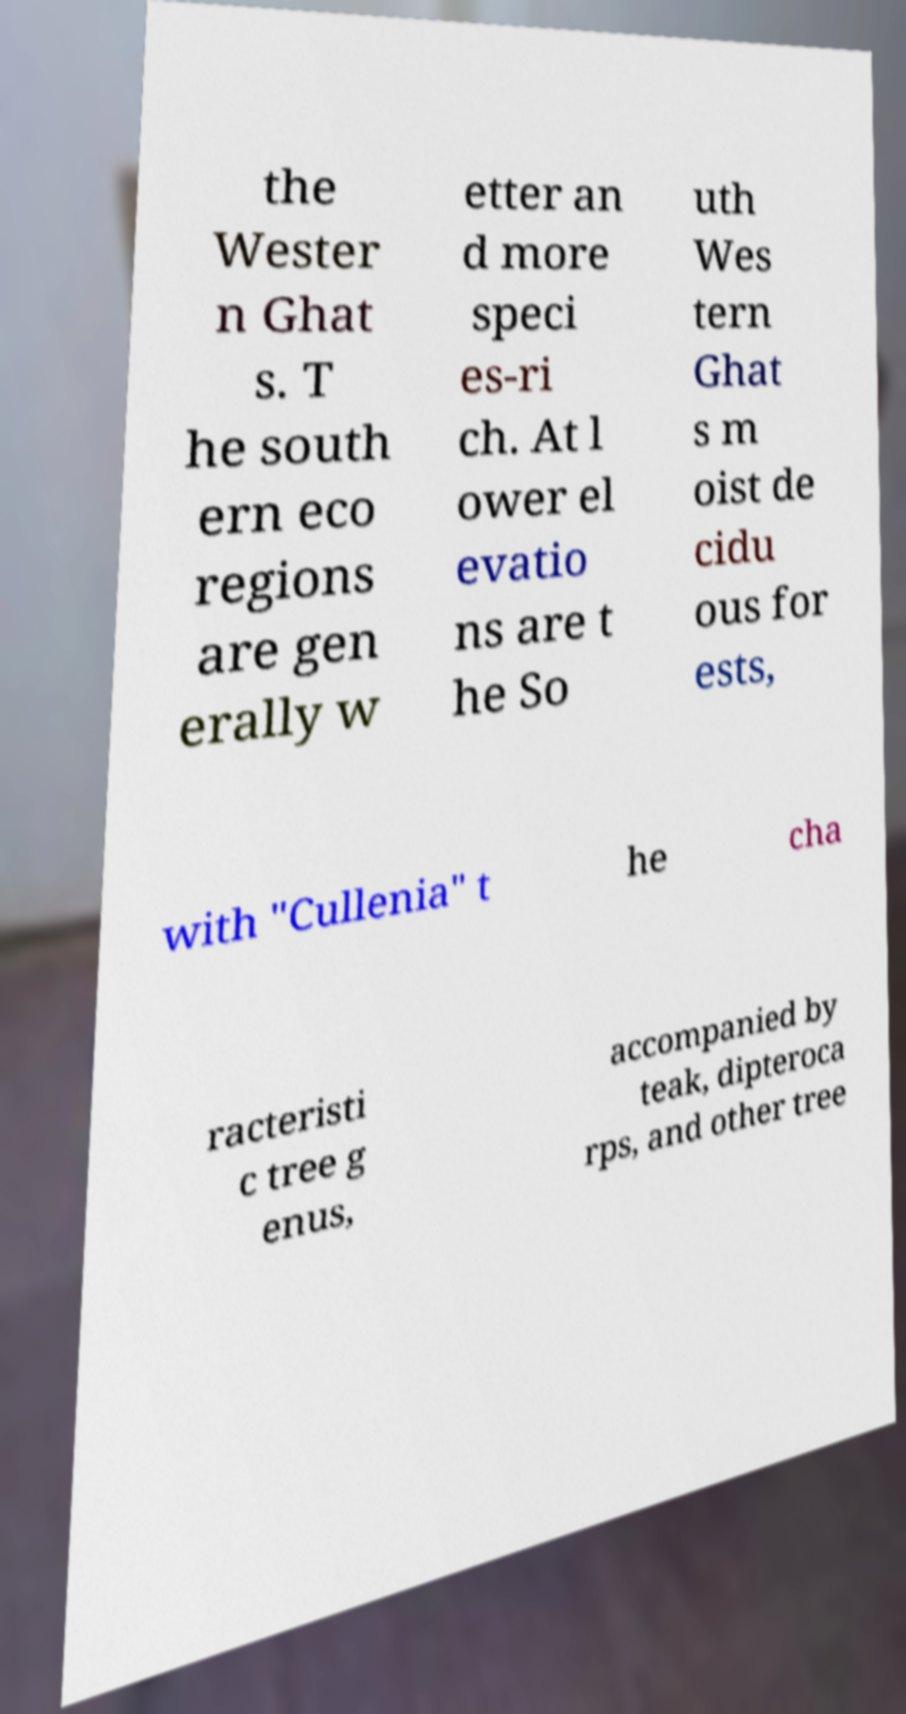Could you assist in decoding the text presented in this image and type it out clearly? the Wester n Ghat s. T he south ern eco regions are gen erally w etter an d more speci es-ri ch. At l ower el evatio ns are t he So uth Wes tern Ghat s m oist de cidu ous for ests, with "Cullenia" t he cha racteristi c tree g enus, accompanied by teak, dipteroca rps, and other tree 